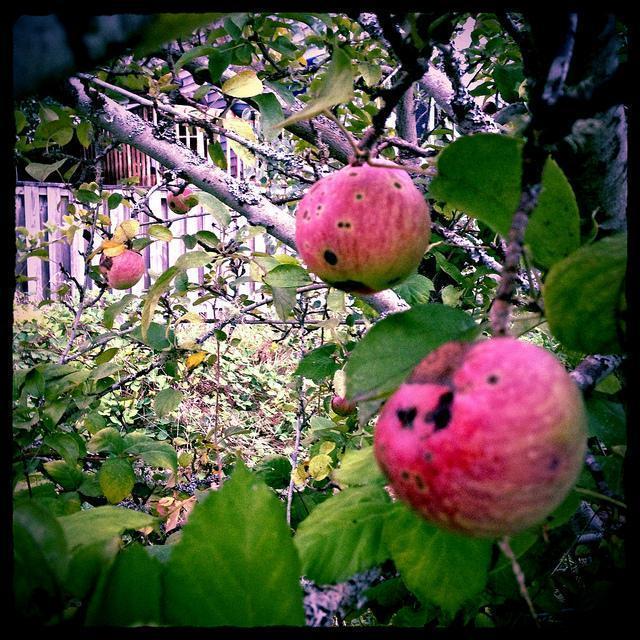Why are there black spots on the apples?
Answer the question by selecting the correct answer among the 4 following choices and explain your choice with a short sentence. The answer should be formatted with the following format: `Answer: choice
Rationale: rationale.`
Options: Fresh, painted, stained, rotting. Answer: rotting.
Rationale: When black spots appear on apples when they have not been picked it means that they are going bad. 